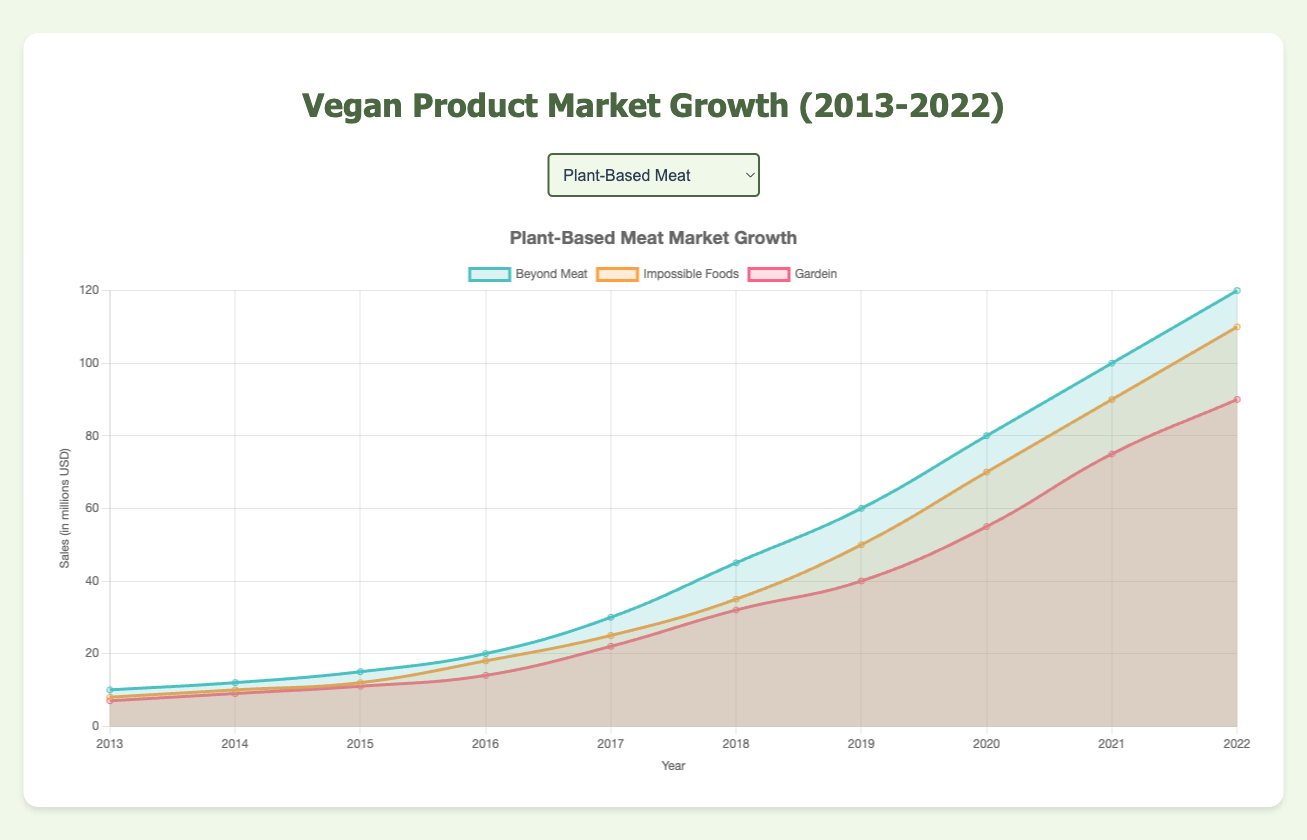What are the total sales for Beyond Meat and Impossible Foods combined in 2022? In 2022, Beyond Meat had sales of 120 million USD, and Impossible Foods had 110 million USD. Adding them together gives 120 + 110 = 230 million USD.
Answer: 230 million USD Which year did Oat Milk surpass Soy Milk in sales? By comparing the sales figures year by year, Oat Milk surpassed Soy Milk in sales in 2018. Oat Milk had 55 million USD, while Soy Milk had 55 million USD in 2018, and in 2019, Oat Milk increased to 75 million USD with Soy Milk at 65 million USD. Therefore, the surpassing point is in 2018
Answer: 2018 Did Coconut Water or Vegan Protein Shakes have a higher growth in sales from 2020 to 2022? In 2020, Coconut Water sales were 90 million USD, and in 2022, they reached 130 million USD. The growth is 130 - 90 = 40 million USD. For Vegan Protein Shakes, sales in 2020 were 90 million USD and reached 130 million USD in 2022. Therefore, growth is similarly 40 million USD. Both had the same growth.
Answer: Same growth What is the average annual sales of Miyoko's Vegan Cheese from 2013 to 2022? The sales for Miyoko's from 2013 to 2022 are: 5, 7, 10, 14, 20, 28, 38, 50, 65, and 85 million USD. Summing these up gives 322 million USD. Dividing by 10 years gives 322 / 10 = 32.2 million USD.
Answer: 32.2 million USD Which category had the highest sales in 2022? By examining the values for 2022, Almond Milk in the Dairy Alternatives category had 160 million USD in sales, which is higher than any other product in any category.
Answer: Dairy Alternatives (Almond Milk) In which year did Beyond Meat's sales grow the most? By inspecting Beyond Meat's sales year by year, the largest growth occurred between 2017 and 2018, where sales increased from 30 million USD to 45 million USD. The growth was 45 - 30 = 15 million USD.
Answer: Most notable growth from 2017 to 2018 Compare the increase in sales of Almond Milk and Oat Milk from 2015 to 2017. Which one had a greater increase? Almond Milk sales were 40 million USD in 2015 and 65 million USD in 2017. The increase is 65 - 40 = 25 million USD. Oat Milk sales were 10 million USD in 2015 and 35 million USD in 2017. The increase is 35 - 10 = 25 million USD. Both Almond Milk and Oat Milk had the same sales increase.
Answer: Same increase How did the sales of Gardein change between 2020 to 2022? In the year 2020, Gardein's sales were 55 million USD, while in 2022, sales increased to 90 million USD. The change in sales is 90 - 55 = 35 million USD.
Answer: 35 million USD increase 